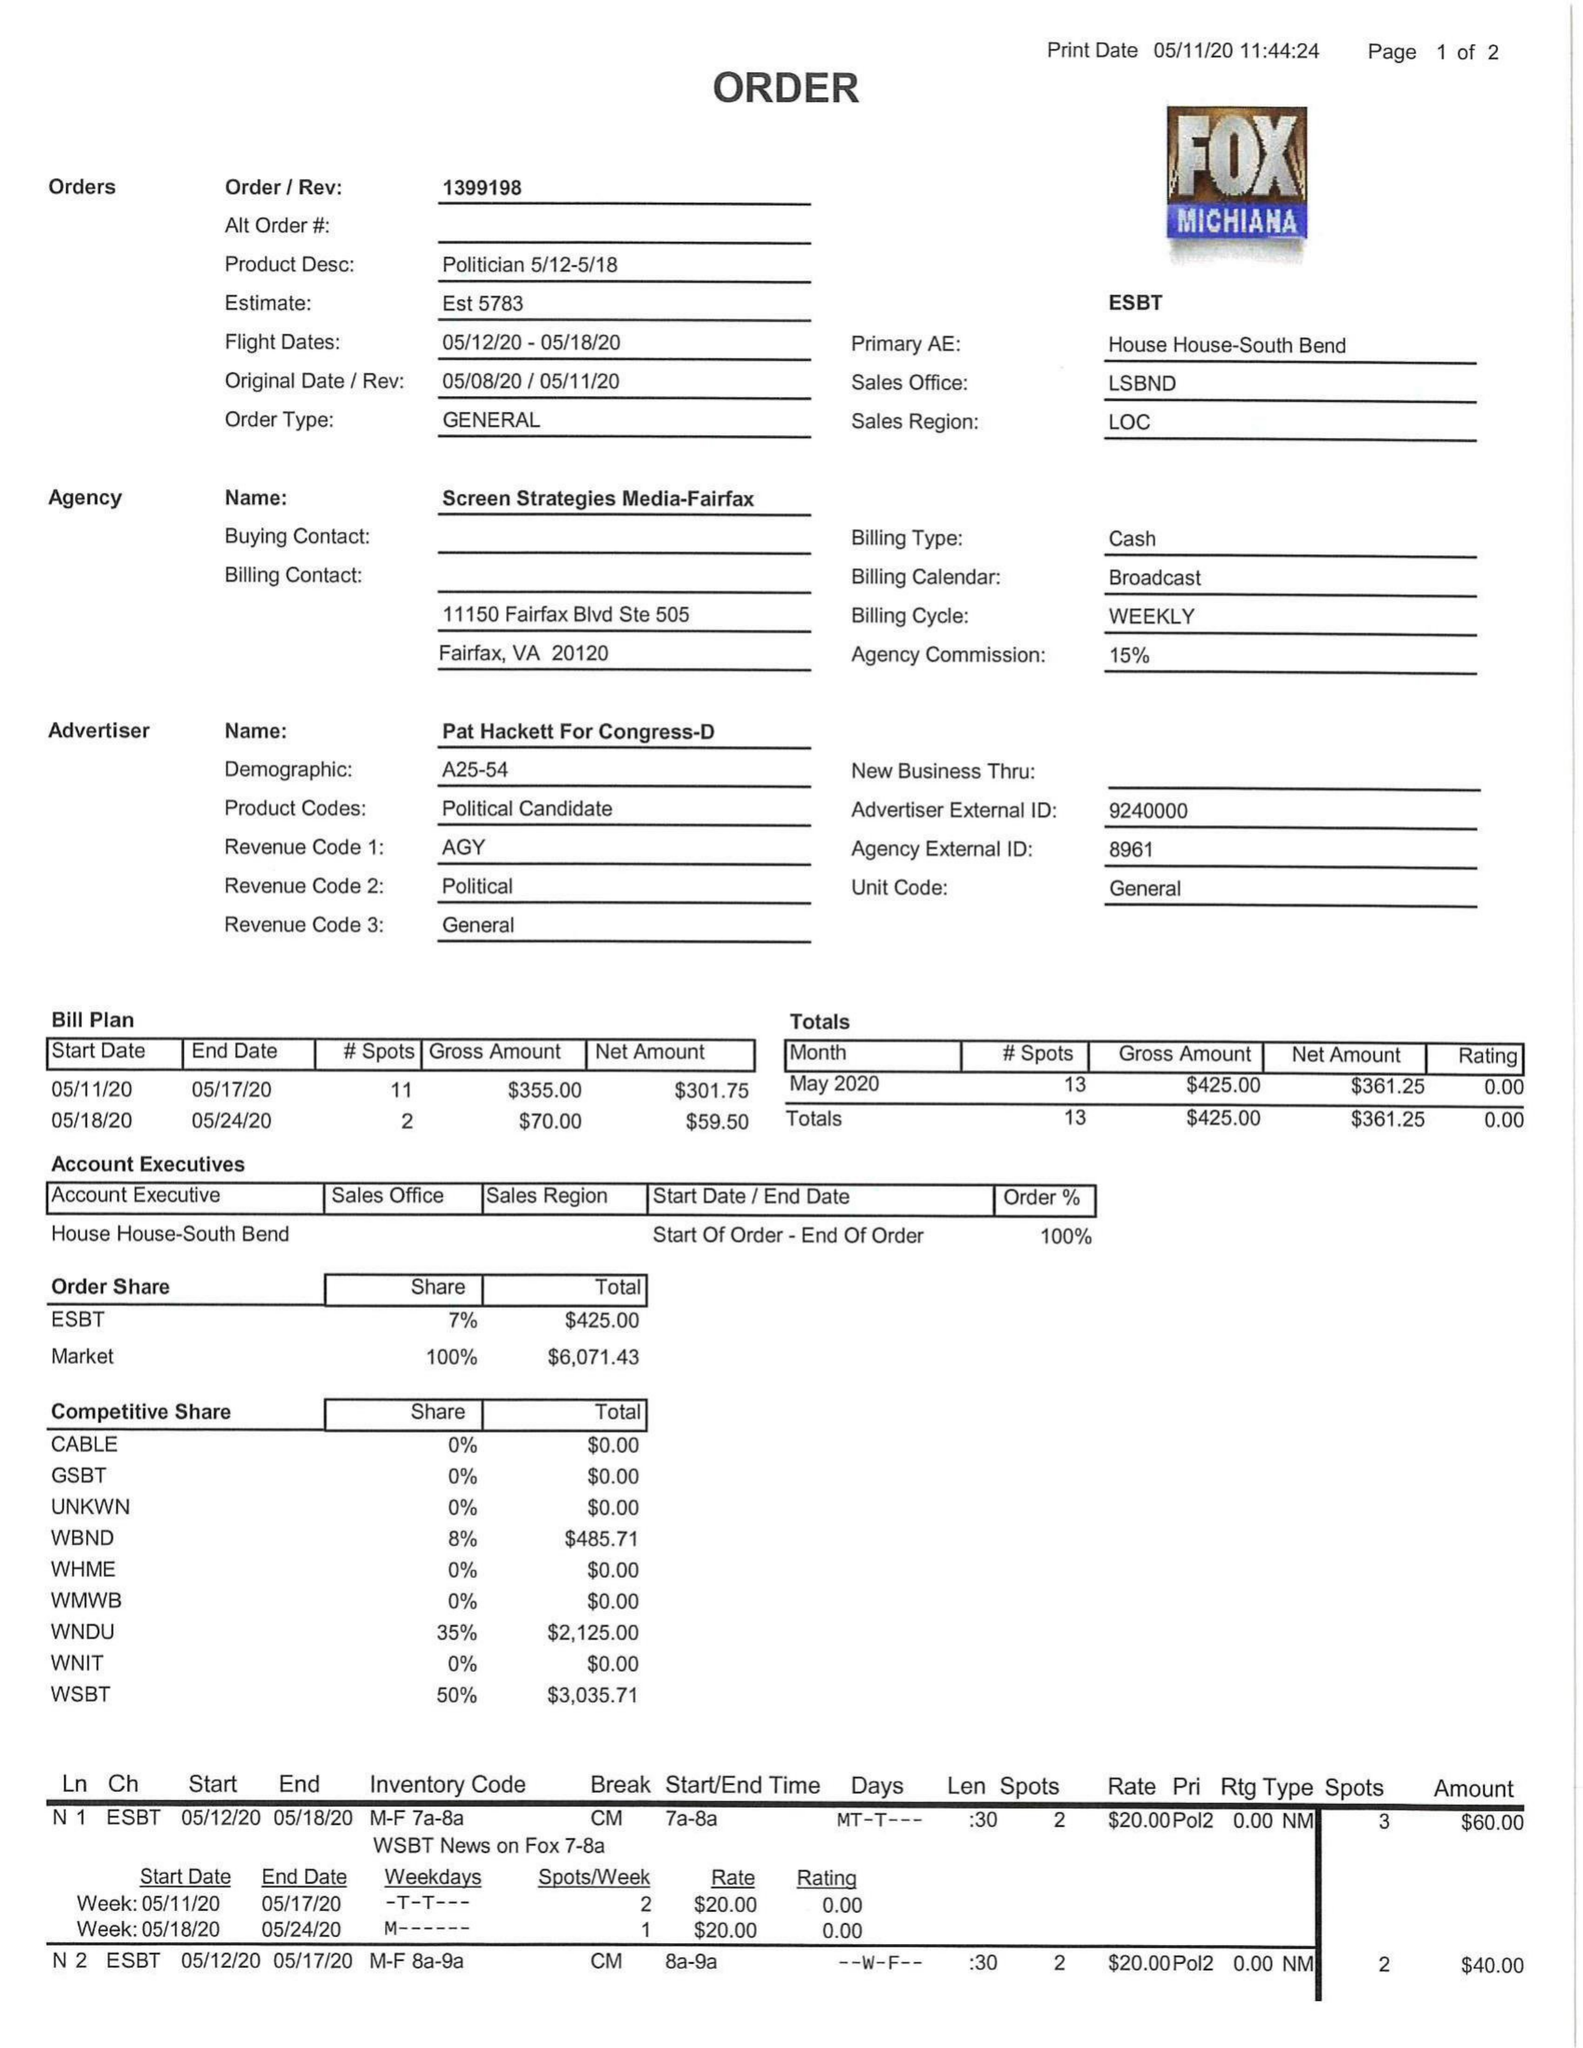What is the value for the flight_from?
Answer the question using a single word or phrase. 05/12/20 